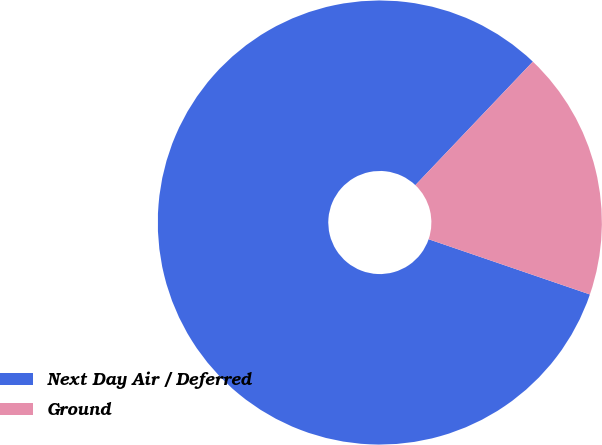Convert chart to OTSL. <chart><loc_0><loc_0><loc_500><loc_500><pie_chart><fcel>Next Day Air / Deferred<fcel>Ground<nl><fcel>81.85%<fcel>18.15%<nl></chart> 